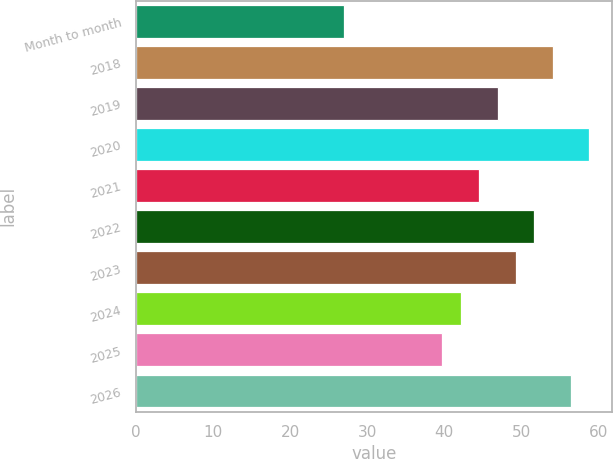Convert chart to OTSL. <chart><loc_0><loc_0><loc_500><loc_500><bar_chart><fcel>Month to month<fcel>2018<fcel>2019<fcel>2020<fcel>2021<fcel>2022<fcel>2023<fcel>2024<fcel>2025<fcel>2026<nl><fcel>27.05<fcel>54.07<fcel>46.93<fcel>58.83<fcel>44.55<fcel>51.69<fcel>49.31<fcel>42.14<fcel>39.76<fcel>56.45<nl></chart> 